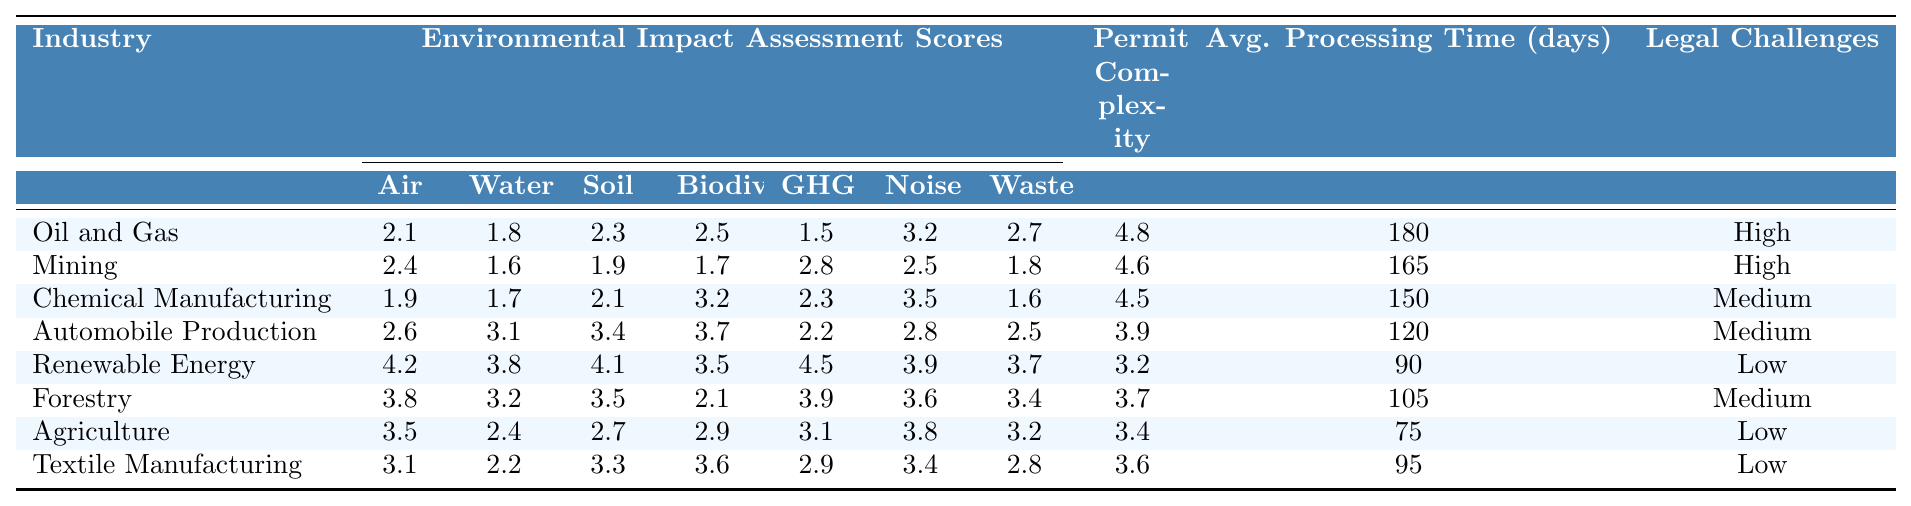What is the environmental impact assessment score for Air Quality in Renewable Energy? The table shows that the score for Air Quality under Renewable Energy is 4.2.
Answer: 4.2 Which industry has the highest score in Greenhouse Gas Emissions? By comparing the scores, Renewable Energy has the highest score of 4.5 in Greenhouse Gas Emissions.
Answer: Renewable Energy What is the average permit complexity rating for the industries listed? The permit complexity ratings are: 4.8, 4.6, 4.5, 3.9, 3.2, 3.7, 3.4, and 3.6. Summing these gives 28.7, divided by 8 industries equals 3.5875, rounded to 3.6.
Answer: 3.6 Is the frequency of legal challenges higher in Agriculture compared to Chemical Manufacturing? The table indicates that Agriculture has a frequency of legal challenges labeled as Low, while Chemical Manufacturing has a frequency labeled as Medium, indicating Chemical Manufacturing has a higher frequency.
Answer: No Which industry has the lowest average permit processing time? The average permit processing times listed are: 180, 165, 150, 120, 90, 105, 75, and 95 days. The lowest value among these is 75 days for Agriculture.
Answer: Agriculture What is the difference in biodiversity loss scores between Automobile Production and Textile Manufacturing? The score for Biodiversity Loss in Automobile Production is 3.7, while in Textile Manufacturing, it is 3.6. The difference is 3.7 - 3.6 = 0.1.
Answer: 0.1 Which industry shows the lowest assessment score for Water Quality? Checking the Water Quality scores, Mining has the lowest score at 1.6.
Answer: Mining Is the average environmental impact assessment score for Noise Pollution higher than 3 for the Oil and Gas industry? The Noise Pollution score for Oil and Gas is 3.2, which is indeed higher than 3.
Answer: Yes What is the sum of the Waste Generation scores for Agriculture and Forestry? The Waste Generation score for Agriculture is 3.2 and for Forestry is 3.4. Summing these yields 3.2 + 3.4 = 6.6.
Answer: 6.6 How many industries have a permit complexity rating greater than 4.0? The industries with ratings greater than 4.0 are Oil and Gas (4.8), Mining (4.6), Chemical Manufacturing (4.5), and Automobile Production (3.9). So, there are 3 industries with ratings greater than 4.0.
Answer: 3 